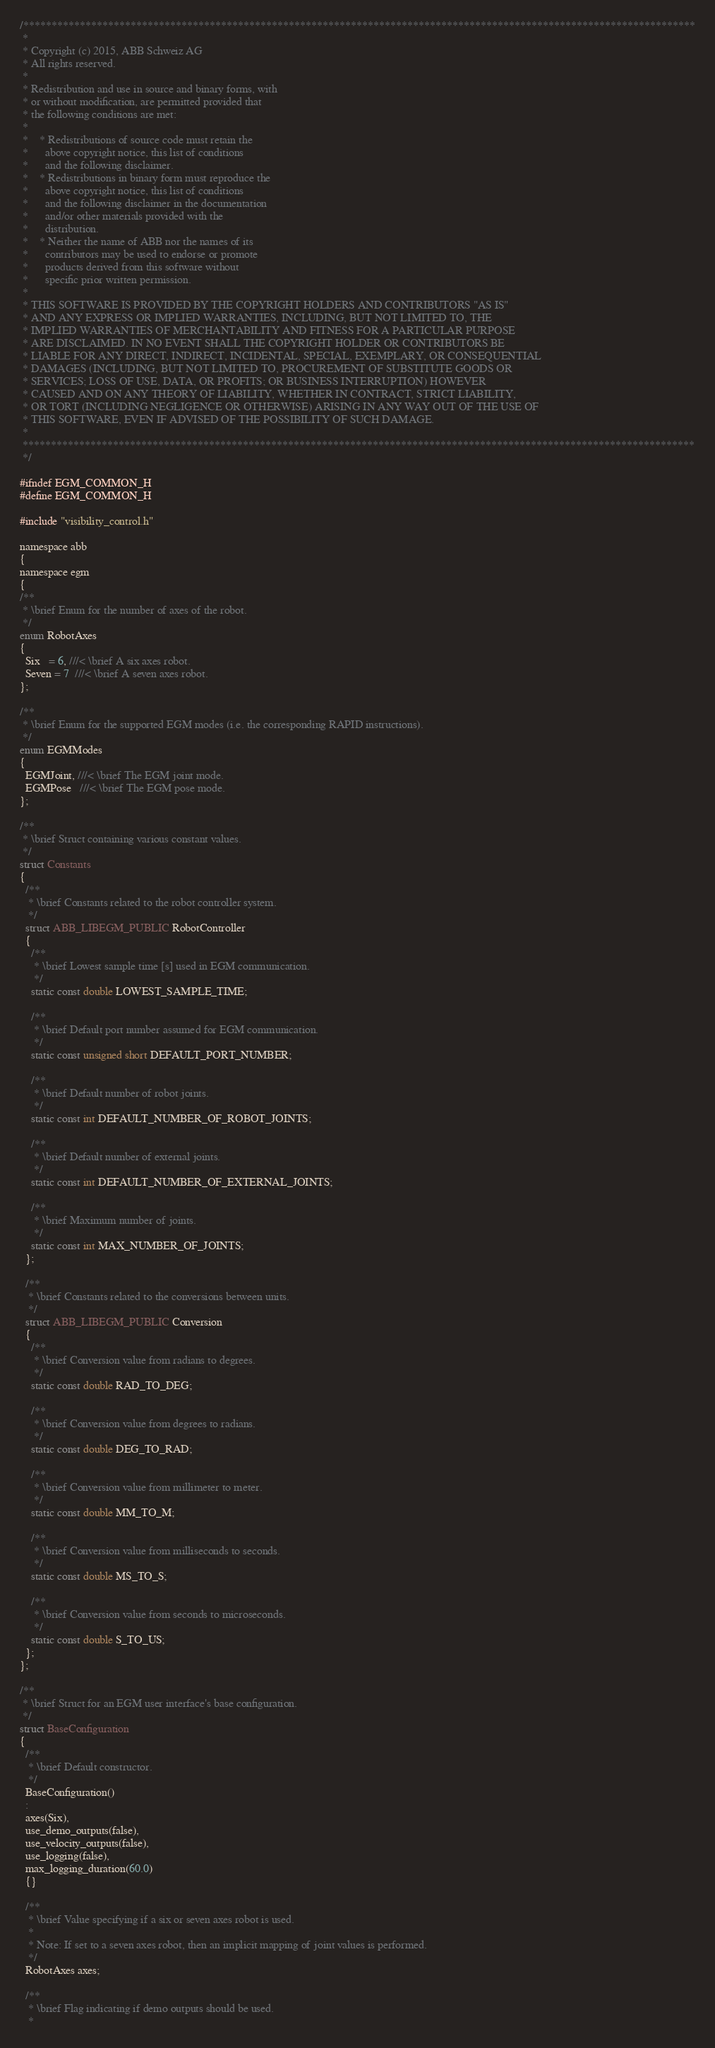Convert code to text. <code><loc_0><loc_0><loc_500><loc_500><_C_>/***********************************************************************************************************************
 *
 * Copyright (c) 2015, ABB Schweiz AG
 * All rights reserved.
 *
 * Redistribution and use in source and binary forms, with
 * or without modification, are permitted provided that
 * the following conditions are met:
 *
 *    * Redistributions of source code must retain the
 *      above copyright notice, this list of conditions
 *      and the following disclaimer.
 *    * Redistributions in binary form must reproduce the
 *      above copyright notice, this list of conditions
 *      and the following disclaimer in the documentation
 *      and/or other materials provided with the
 *      distribution.
 *    * Neither the name of ABB nor the names of its
 *      contributors may be used to endorse or promote
 *      products derived from this software without
 *      specific prior written permission.
 *
 * THIS SOFTWARE IS PROVIDED BY THE COPYRIGHT HOLDERS AND CONTRIBUTORS "AS IS"
 * AND ANY EXPRESS OR IMPLIED WARRANTIES, INCLUDING, BUT NOT LIMITED TO, THE
 * IMPLIED WARRANTIES OF MERCHANTABILITY AND FITNESS FOR A PARTICULAR PURPOSE
 * ARE DISCLAIMED. IN NO EVENT SHALL THE COPYRIGHT HOLDER OR CONTRIBUTORS BE
 * LIABLE FOR ANY DIRECT, INDIRECT, INCIDENTAL, SPECIAL, EXEMPLARY, OR CONSEQUENTIAL
 * DAMAGES (INCLUDING, BUT NOT LIMITED TO, PROCUREMENT OF SUBSTITUTE GOODS OR
 * SERVICES; LOSS OF USE, DATA, OR PROFITS; OR BUSINESS INTERRUPTION) HOWEVER
 * CAUSED AND ON ANY THEORY OF LIABILITY, WHETHER IN CONTRACT, STRICT LIABILITY,
 * OR TORT (INCLUDING NEGLIGENCE OR OTHERWISE) ARISING IN ANY WAY OUT OF THE USE OF
 * THIS SOFTWARE, EVEN IF ADVISED OF THE POSSIBILITY OF SUCH DAMAGE.
 *
 ***********************************************************************************************************************
 */

#ifndef EGM_COMMON_H
#define EGM_COMMON_H

#include "visibility_control.h"

namespace abb
{
namespace egm
{
/**
 * \brief Enum for the number of axes of the robot.
 */
enum RobotAxes
{
  Six   = 6, ///< \brief A six axes robot.
  Seven = 7  ///< \brief A seven axes robot.
};

/**
 * \brief Enum for the supported EGM modes (i.e. the corresponding RAPID instructions).
 */
enum EGMModes
{
  EGMJoint, ///< \brief The EGM joint mode.
  EGMPose   ///< \brief The EGM pose mode.
};

/**
 * \brief Struct containing various constant values.
 */
struct Constants
{
  /**
   * \brief Constants related to the robot controller system.
   */
  struct ABB_LIBEGM_PUBLIC RobotController
  {
    /**
     * \brief Lowest sample time [s] used in EGM communication.
     */
    static const double LOWEST_SAMPLE_TIME;

    /**
     * \brief Default port number assumed for EGM communication.
     */
    static const unsigned short DEFAULT_PORT_NUMBER;

    /**
     * \brief Default number of robot joints.
     */
    static const int DEFAULT_NUMBER_OF_ROBOT_JOINTS;

    /**
     * \brief Default number of external joints.
     */
    static const int DEFAULT_NUMBER_OF_EXTERNAL_JOINTS;

    /**
     * \brief Maximum number of joints.
     */
    static const int MAX_NUMBER_OF_JOINTS;
  };

  /**
   * \brief Constants related to the conversions between units.
   */
  struct ABB_LIBEGM_PUBLIC Conversion
  {
    /**
     * \brief Conversion value from radians to degrees.
     */
    static const double RAD_TO_DEG;

    /**
     * \brief Conversion value from degrees to radians.
     */
    static const double DEG_TO_RAD;

    /**
     * \brief Conversion value from millimeter to meter.
     */
    static const double MM_TO_M;

    /**
     * \brief Conversion value from milliseconds to seconds.
     */
    static const double MS_TO_S;

    /**
     * \brief Conversion value from seconds to microseconds.
     */
    static const double S_TO_US;
  };
};

/**
 * \brief Struct for an EGM user interface's base configuration.
 */
struct BaseConfiguration
{
  /**
   * \brief Default constructor.
   */
  BaseConfiguration()
  :
  axes(Six),
  use_demo_outputs(false),
  use_velocity_outputs(false),
  use_logging(false),
  max_logging_duration(60.0)
  {}

  /**
   * \brief Value specifying if a six or seven axes robot is used.
   *
   * Note: If set to a seven axes robot, then an implicit mapping of joint values is performed.
   */
  RobotAxes axes;

  /**
   * \brief Flag indicating if demo outputs should be used.
   *</code> 